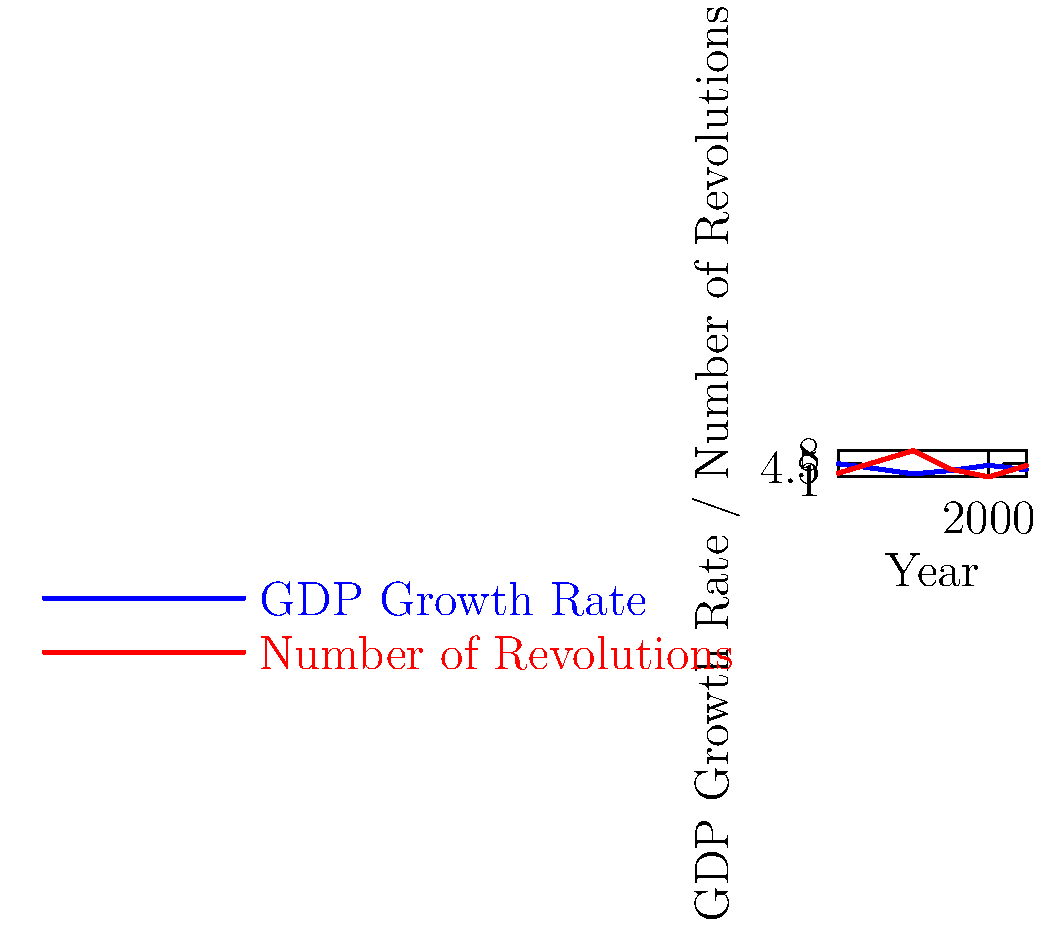Based on the line graph showing GDP growth rates and the frequency of revolutions from 1960 to 2010, what relationship can be observed between economic performance and revolutionary activity? How does this support or challenge the notion that economic factors are the primary drivers of revolutions? To answer this question, we need to analyze the relationship between GDP growth rates and the number of revolutions over time:

1. Observe the trends:
   - GDP growth rate (blue line) fluctuates between 1.8% and 4.5%
   - Number of revolutions (red line) varies from 1 to 8

2. Look for patterns:
   - 1960-1980: As GDP growth decreases, revolutions increase
   - 1980-1990: Both GDP growth and revolutions decrease
   - 1990-2000: As GDP growth increases, revolutions decrease
   - 2000-2010: As GDP growth decreases, revolutions increase

3. Analyze the relationship:
   - There appears to be a generally inverse relationship between GDP growth and revolutions
   - When economic performance declines (lower GDP growth), revolutionary activity tends to increase
   - When economic performance improves (higher GDP growth), revolutionary activity tends to decrease

4. Consider exceptions:
   - The period from 1980 to 1990 shows both GDP growth and revolutions decreasing, which doesn't fit the overall pattern

5. Evaluate the economic factor hypothesis:
   - The observed inverse relationship largely supports the notion that economic factors drive revolutions
   - However, the exception in 1980-1990 suggests other factors may also play a role

6. Consider limitations:
   - The data only covers 1960-2010, so it may not represent all historical periods
   - The graph doesn't account for other potential factors influencing revolutions (e.g., political, social, or cultural factors)
Answer: The graph generally shows an inverse relationship between GDP growth and revolutions, supporting the economic factor hypothesis, but exceptions suggest other influences may also play a role in revolutionary activity. 